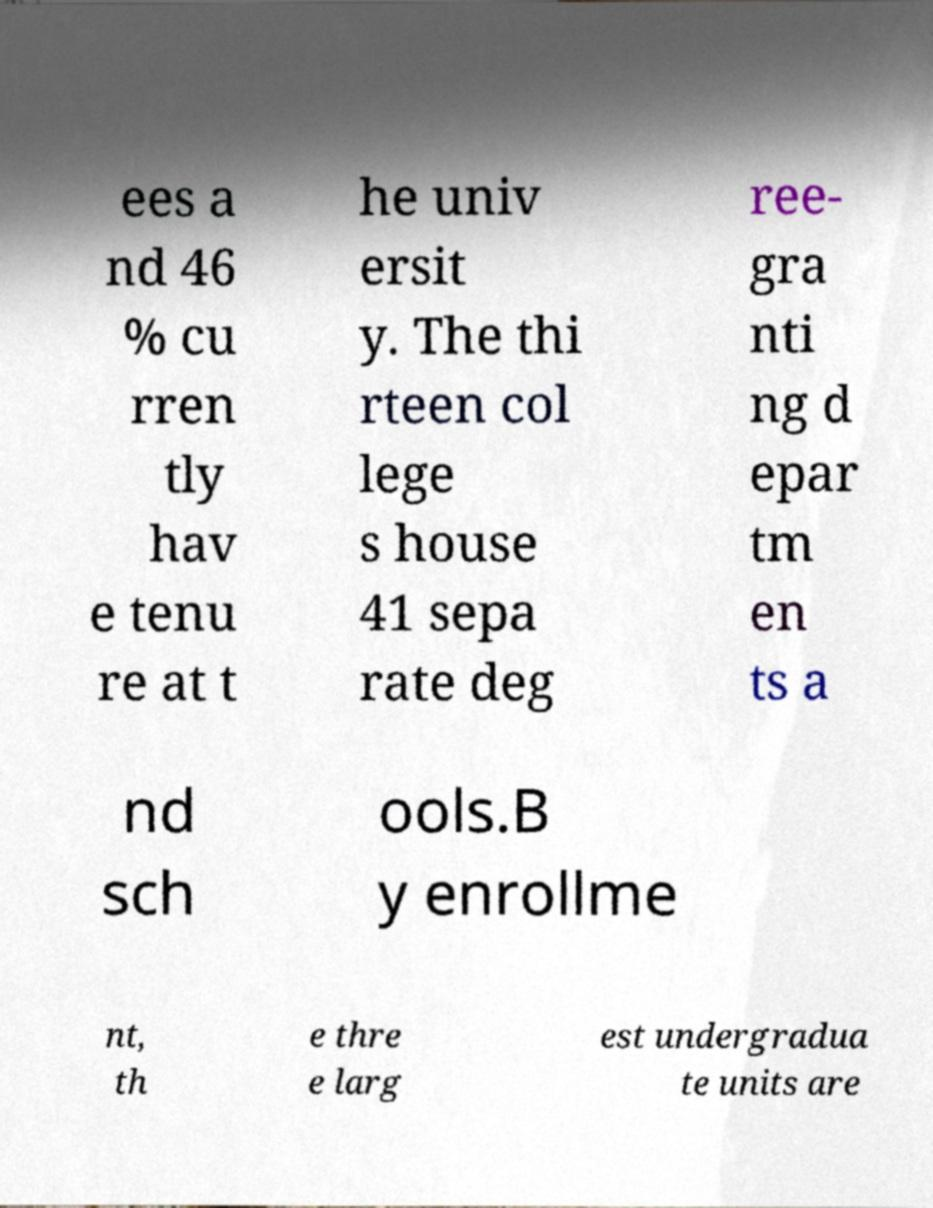What messages or text are displayed in this image? I need them in a readable, typed format. ees a nd 46 % cu rren tly hav e tenu re at t he univ ersit y. The thi rteen col lege s house 41 sepa rate deg ree- gra nti ng d epar tm en ts a nd sch ools.B y enrollme nt, th e thre e larg est undergradua te units are 